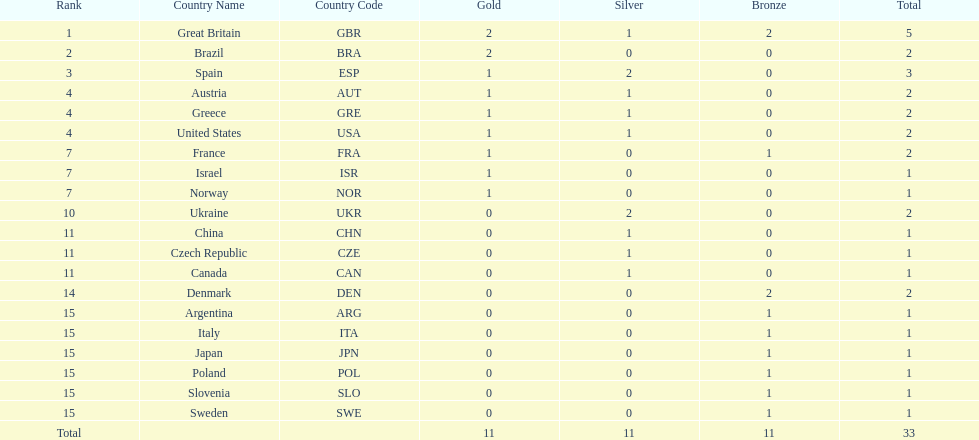What nation was next to great britain in total medal count? Spain. 